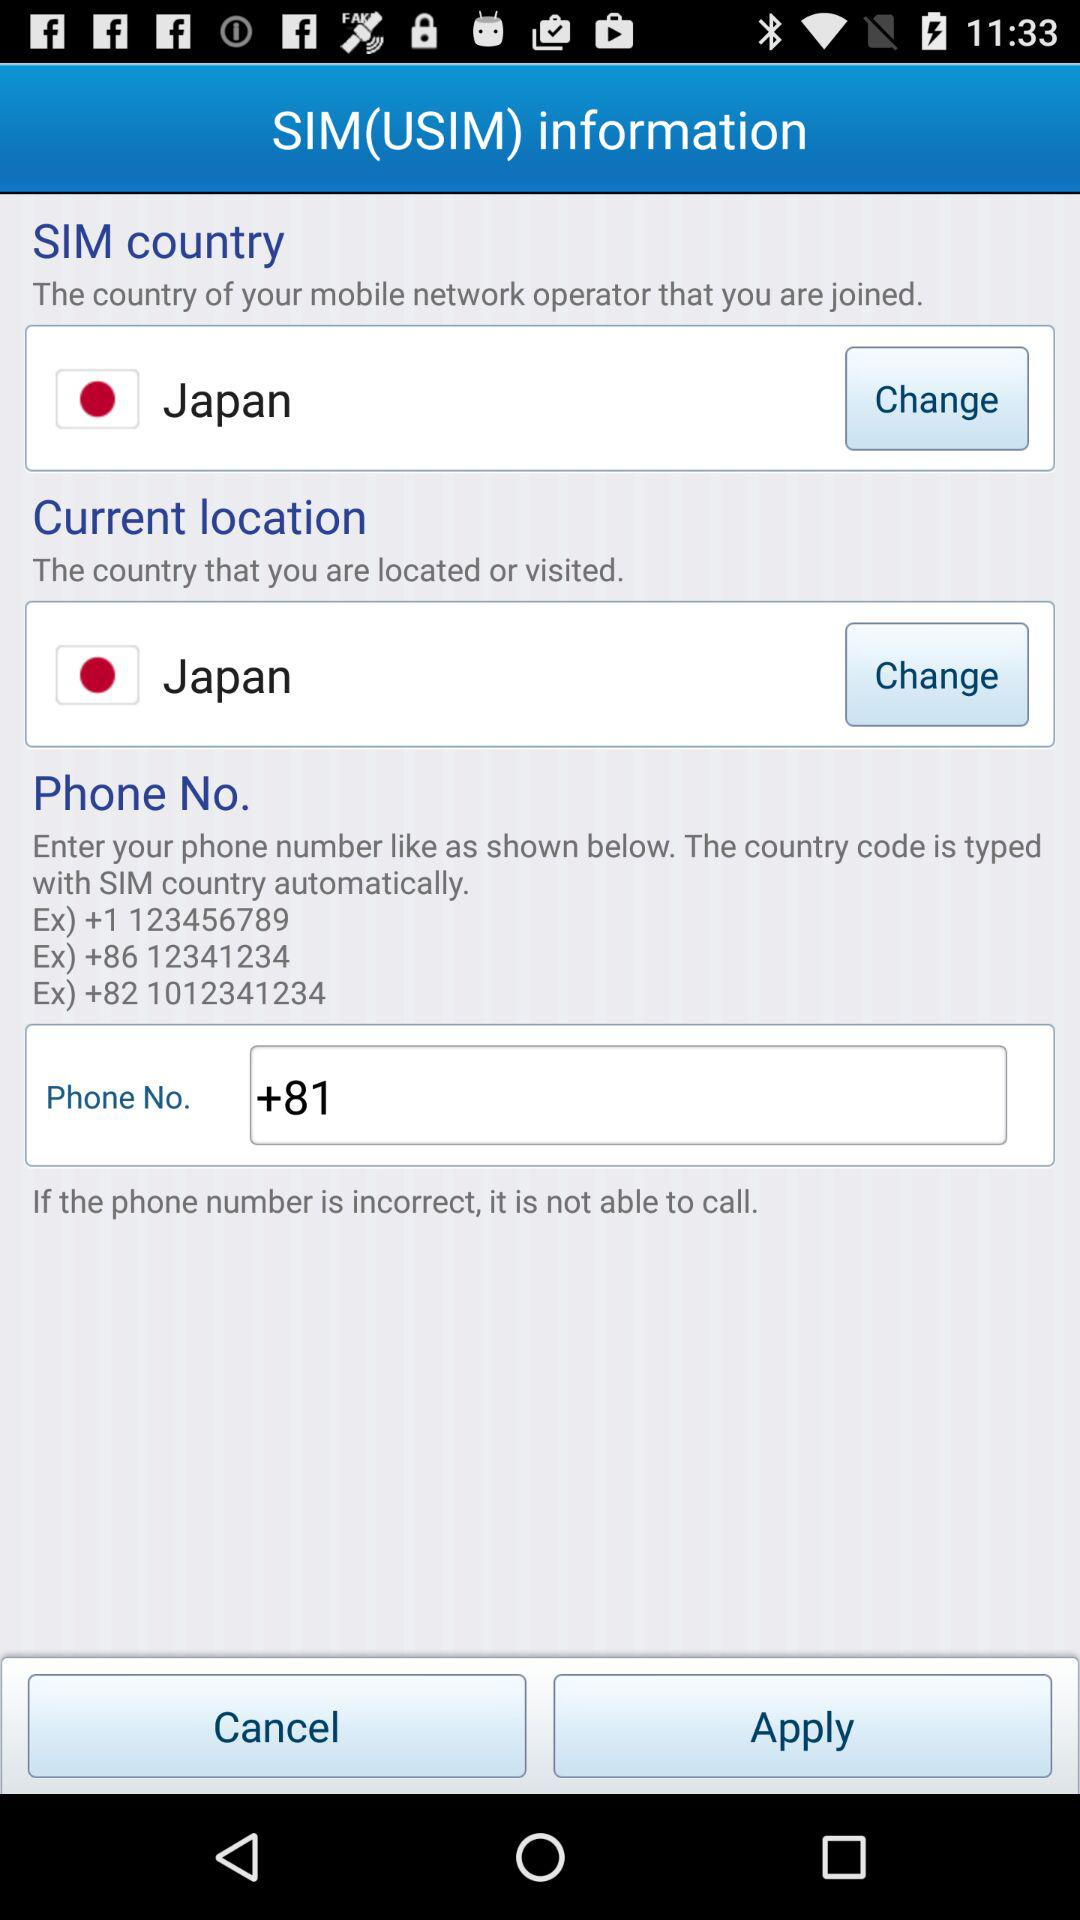Which country code is entered in the phone no. field? The entered country code is +81. 